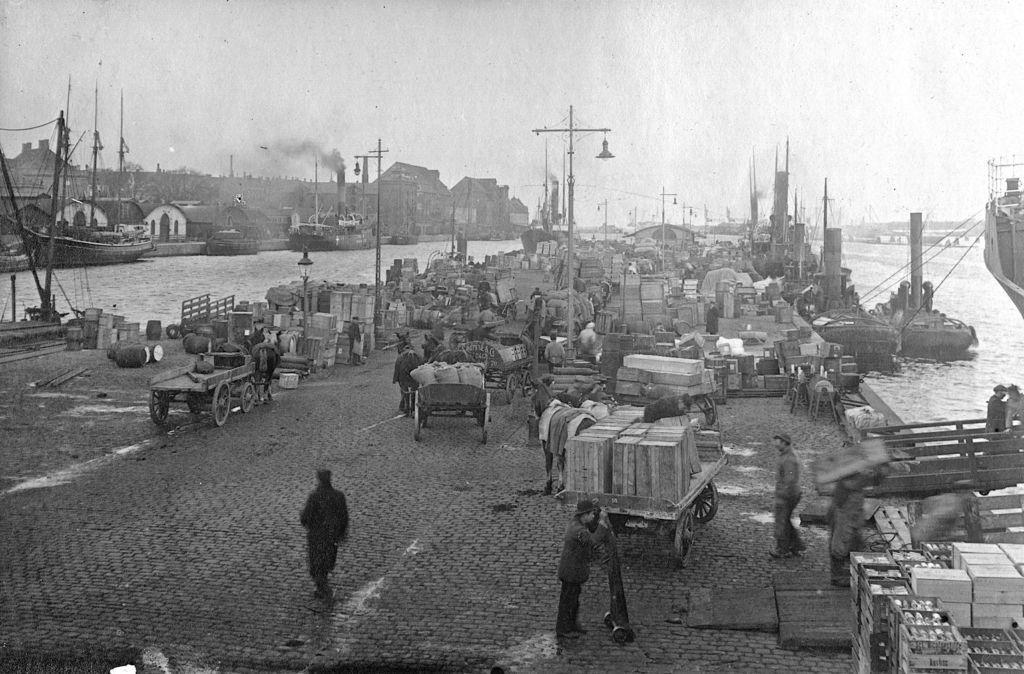Could you give a brief overview of what you see in this image? This is a black and white picture. There are carts, horses, poles, boxes, and few persons. This is water. In the background we can see houses, smoke, and sky. 